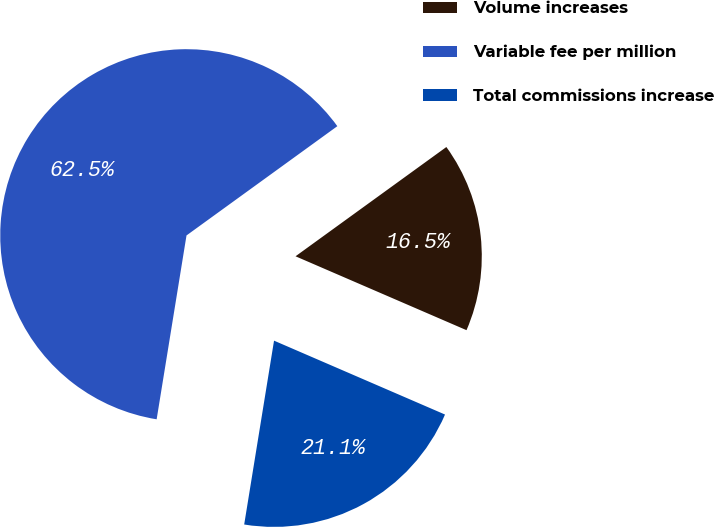<chart> <loc_0><loc_0><loc_500><loc_500><pie_chart><fcel>Volume increases<fcel>Variable fee per million<fcel>Total commissions increase<nl><fcel>16.47%<fcel>62.46%<fcel>21.07%<nl></chart> 